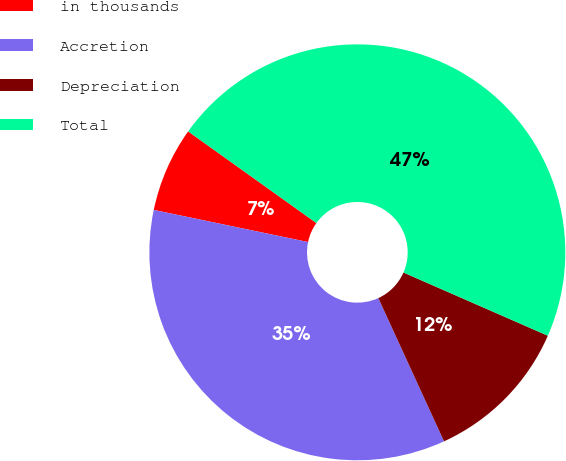Convert chart. <chart><loc_0><loc_0><loc_500><loc_500><pie_chart><fcel>in thousands<fcel>Accretion<fcel>Depreciation<fcel>Total<nl><fcel>6.61%<fcel>35.11%<fcel>11.59%<fcel>46.69%<nl></chart> 